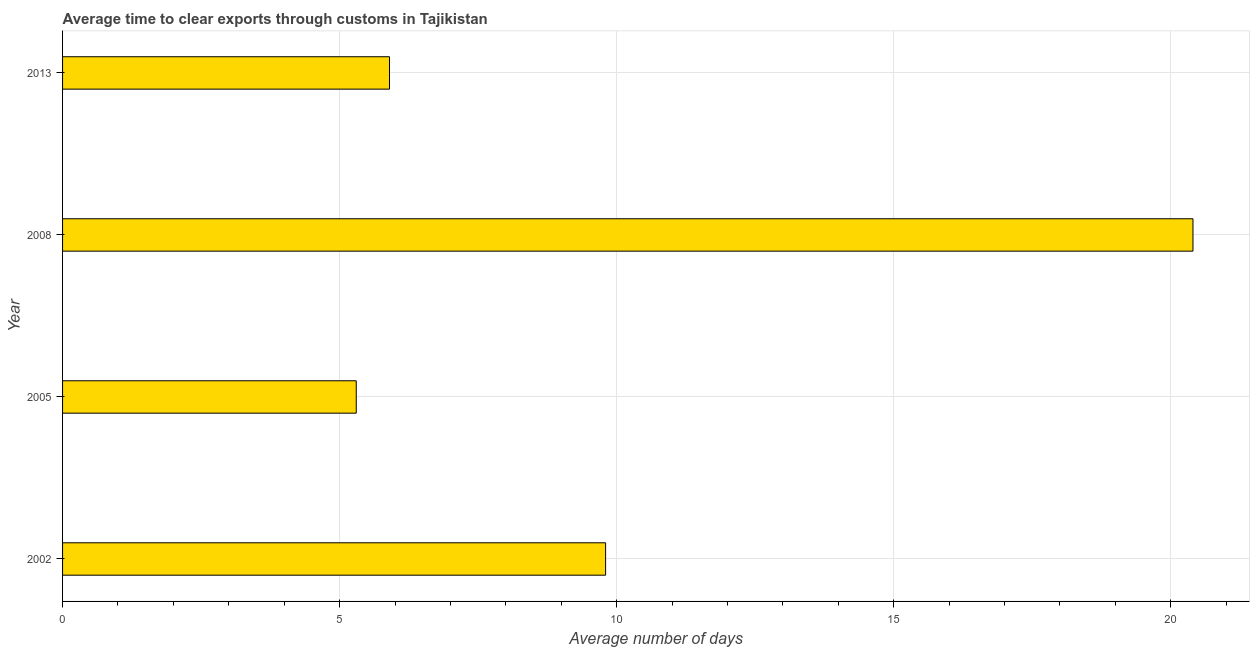Does the graph contain any zero values?
Make the answer very short. No. Does the graph contain grids?
Give a very brief answer. Yes. What is the title of the graph?
Offer a terse response. Average time to clear exports through customs in Tajikistan. What is the label or title of the X-axis?
Your answer should be compact. Average number of days. What is the label or title of the Y-axis?
Give a very brief answer. Year. Across all years, what is the maximum time to clear exports through customs?
Provide a short and direct response. 20.4. Across all years, what is the minimum time to clear exports through customs?
Provide a short and direct response. 5.3. What is the sum of the time to clear exports through customs?
Offer a terse response. 41.4. What is the difference between the time to clear exports through customs in 2002 and 2013?
Your answer should be very brief. 3.9. What is the average time to clear exports through customs per year?
Offer a very short reply. 10.35. What is the median time to clear exports through customs?
Give a very brief answer. 7.85. In how many years, is the time to clear exports through customs greater than 17 days?
Ensure brevity in your answer.  1. What is the ratio of the time to clear exports through customs in 2008 to that in 2013?
Provide a short and direct response. 3.46. Is the difference between the time to clear exports through customs in 2002 and 2008 greater than the difference between any two years?
Your response must be concise. No. What is the difference between the highest and the second highest time to clear exports through customs?
Your response must be concise. 10.6. How many bars are there?
Provide a short and direct response. 4. Are all the bars in the graph horizontal?
Your answer should be very brief. Yes. How many years are there in the graph?
Give a very brief answer. 4. What is the difference between two consecutive major ticks on the X-axis?
Offer a terse response. 5. What is the Average number of days of 2002?
Keep it short and to the point. 9.8. What is the Average number of days in 2005?
Make the answer very short. 5.3. What is the Average number of days in 2008?
Ensure brevity in your answer.  20.4. What is the difference between the Average number of days in 2002 and 2013?
Offer a very short reply. 3.9. What is the difference between the Average number of days in 2005 and 2008?
Provide a short and direct response. -15.1. What is the ratio of the Average number of days in 2002 to that in 2005?
Your answer should be compact. 1.85. What is the ratio of the Average number of days in 2002 to that in 2008?
Provide a short and direct response. 0.48. What is the ratio of the Average number of days in 2002 to that in 2013?
Make the answer very short. 1.66. What is the ratio of the Average number of days in 2005 to that in 2008?
Ensure brevity in your answer.  0.26. What is the ratio of the Average number of days in 2005 to that in 2013?
Give a very brief answer. 0.9. What is the ratio of the Average number of days in 2008 to that in 2013?
Offer a terse response. 3.46. 